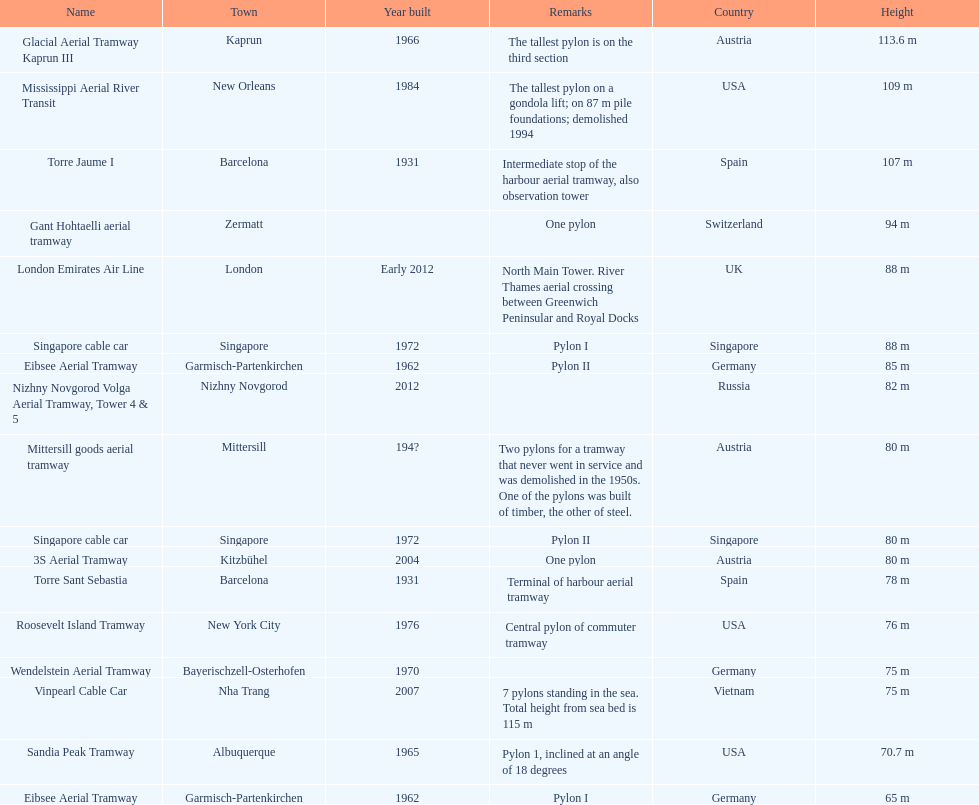Can you parse all the data within this table? {'header': ['Name', 'Town', 'Year built', 'Remarks', 'Country', 'Height'], 'rows': [['Glacial Aerial Tramway Kaprun III', 'Kaprun', '1966', 'The tallest pylon is on the third section', 'Austria', '113.6 m'], ['Mississippi Aerial River Transit', 'New Orleans', '1984', 'The tallest pylon on a gondola lift; on 87 m pile foundations; demolished 1994', 'USA', '109 m'], ['Torre Jaume I', 'Barcelona', '1931', 'Intermediate stop of the harbour aerial tramway, also observation tower', 'Spain', '107 m'], ['Gant Hohtaelli aerial tramway', 'Zermatt', '', 'One pylon', 'Switzerland', '94 m'], ['London Emirates Air Line', 'London', 'Early 2012', 'North Main Tower. River Thames aerial crossing between Greenwich Peninsular and Royal Docks', 'UK', '88 m'], ['Singapore cable car', 'Singapore', '1972', 'Pylon I', 'Singapore', '88 m'], ['Eibsee Aerial Tramway', 'Garmisch-Partenkirchen', '1962', 'Pylon II', 'Germany', '85 m'], ['Nizhny Novgorod Volga Aerial Tramway, Tower 4 & 5', 'Nizhny Novgorod', '2012', '', 'Russia', '82 m'], ['Mittersill goods aerial tramway', 'Mittersill', '194?', 'Two pylons for a tramway that never went in service and was demolished in the 1950s. One of the pylons was built of timber, the other of steel.', 'Austria', '80 m'], ['Singapore cable car', 'Singapore', '1972', 'Pylon II', 'Singapore', '80 m'], ['3S Aerial Tramway', 'Kitzbühel', '2004', 'One pylon', 'Austria', '80 m'], ['Torre Sant Sebastia', 'Barcelona', '1931', 'Terminal of harbour aerial tramway', 'Spain', '78 m'], ['Roosevelt Island Tramway', 'New York City', '1976', 'Central pylon of commuter tramway', 'USA', '76 m'], ['Wendelstein Aerial Tramway', 'Bayerischzell-Osterhofen', '1970', '', 'Germany', '75 m'], ['Vinpearl Cable Car', 'Nha Trang', '2007', '7 pylons standing in the sea. Total height from sea bed is 115 m', 'Vietnam', '75 m'], ['Sandia Peak Tramway', 'Albuquerque', '1965', 'Pylon 1, inclined at an angle of 18 degrees', 'USA', '70.7 m'], ['Eibsee Aerial Tramway', 'Garmisch-Partenkirchen', '1962', 'Pylon I', 'Germany', '65 m']]} How many metres is the tallest pylon? 113.6 m. 